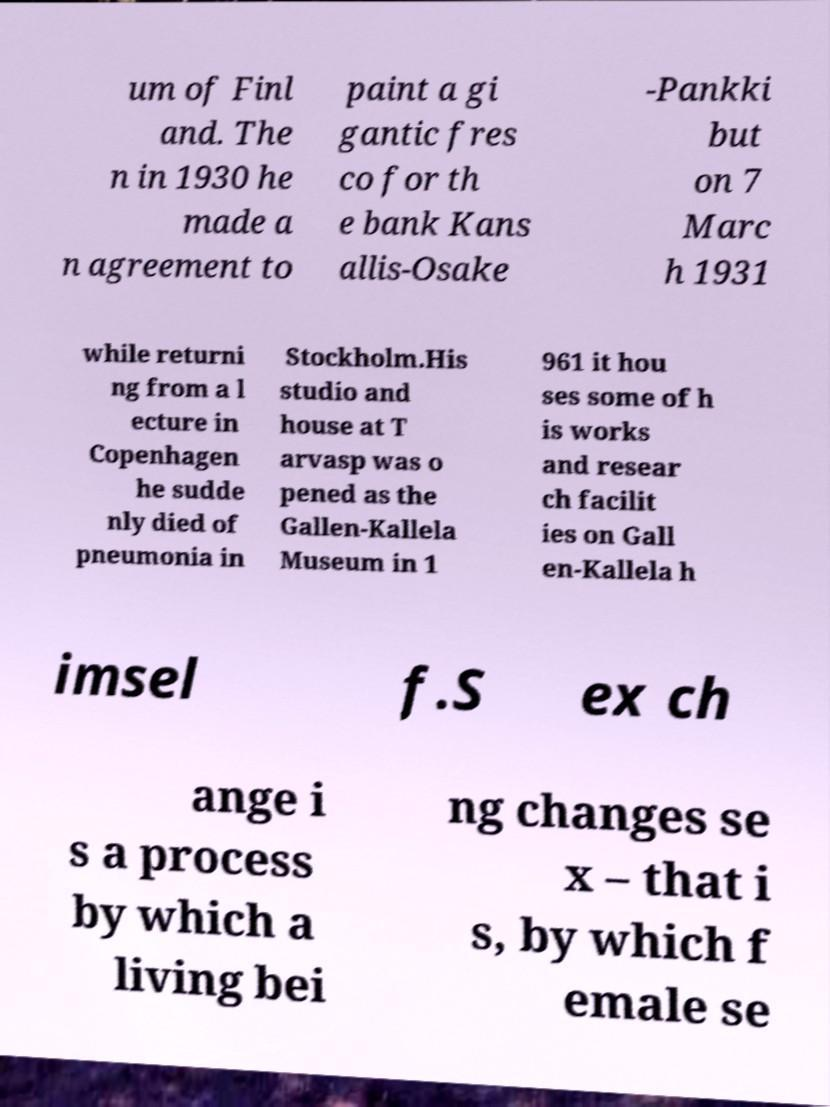What messages or text are displayed in this image? I need them in a readable, typed format. um of Finl and. The n in 1930 he made a n agreement to paint a gi gantic fres co for th e bank Kans allis-Osake -Pankki but on 7 Marc h 1931 while returni ng from a l ecture in Copenhagen he sudde nly died of pneumonia in Stockholm.His studio and house at T arvasp was o pened as the Gallen-Kallela Museum in 1 961 it hou ses some of h is works and resear ch facilit ies on Gall en-Kallela h imsel f.S ex ch ange i s a process by which a living bei ng changes se x – that i s, by which f emale se 